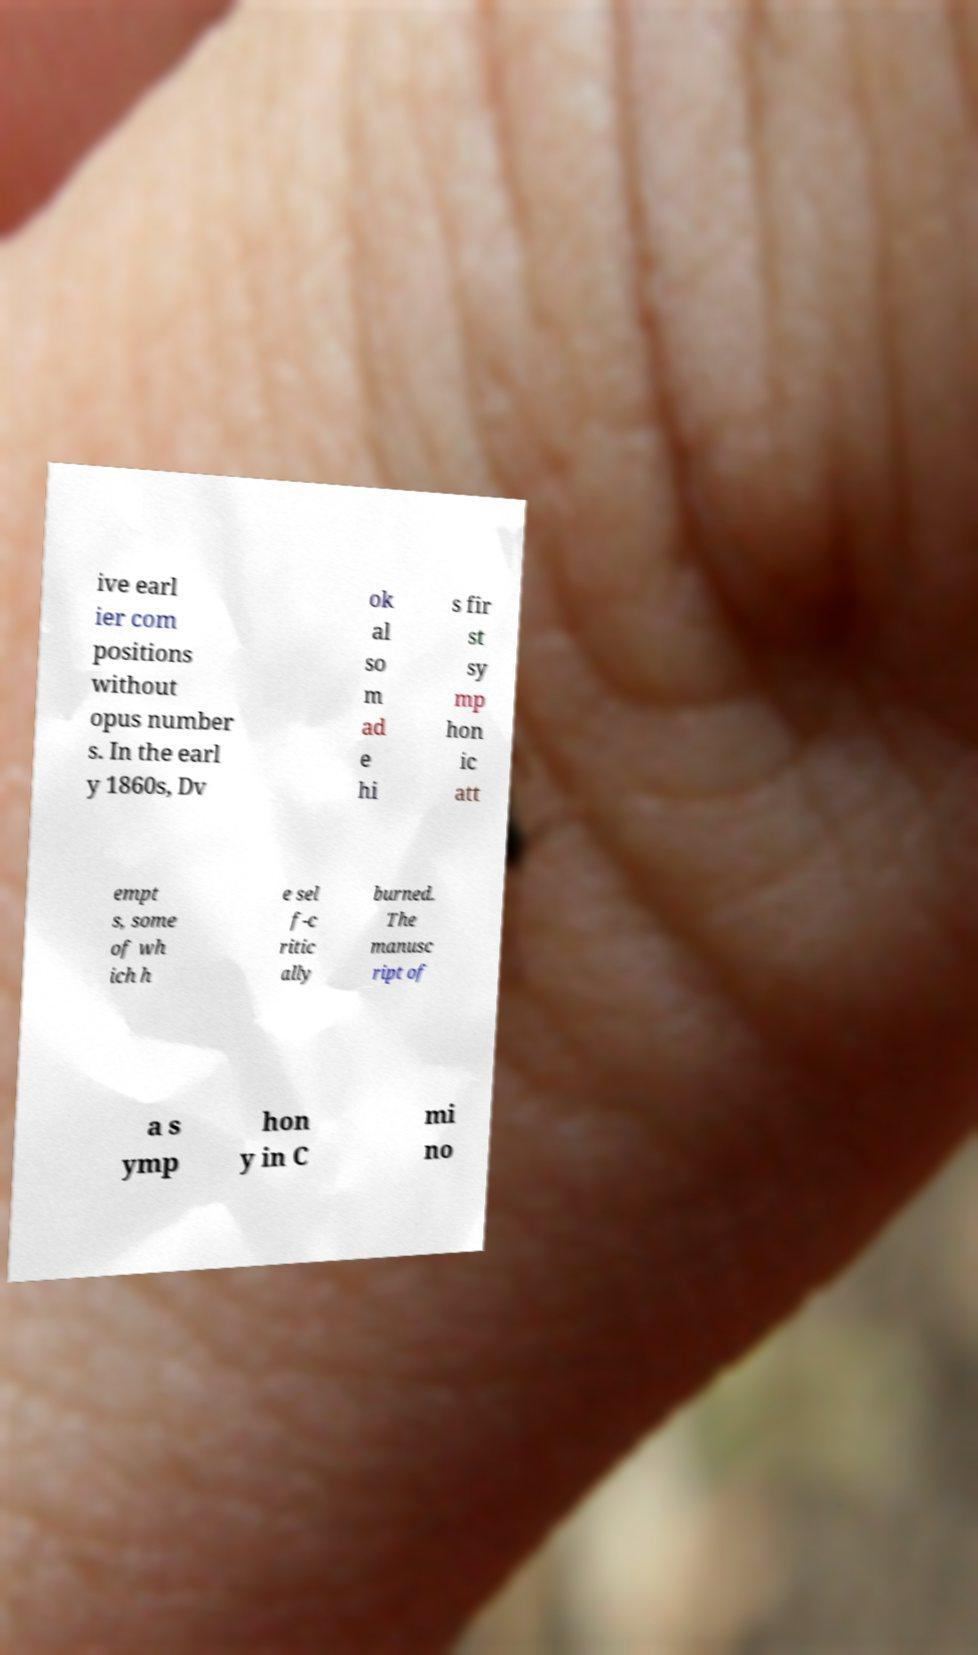Please identify and transcribe the text found in this image. ive earl ier com positions without opus number s. In the earl y 1860s, Dv ok al so m ad e hi s fir st sy mp hon ic att empt s, some of wh ich h e sel f-c ritic ally burned. The manusc ript of a s ymp hon y in C mi no 